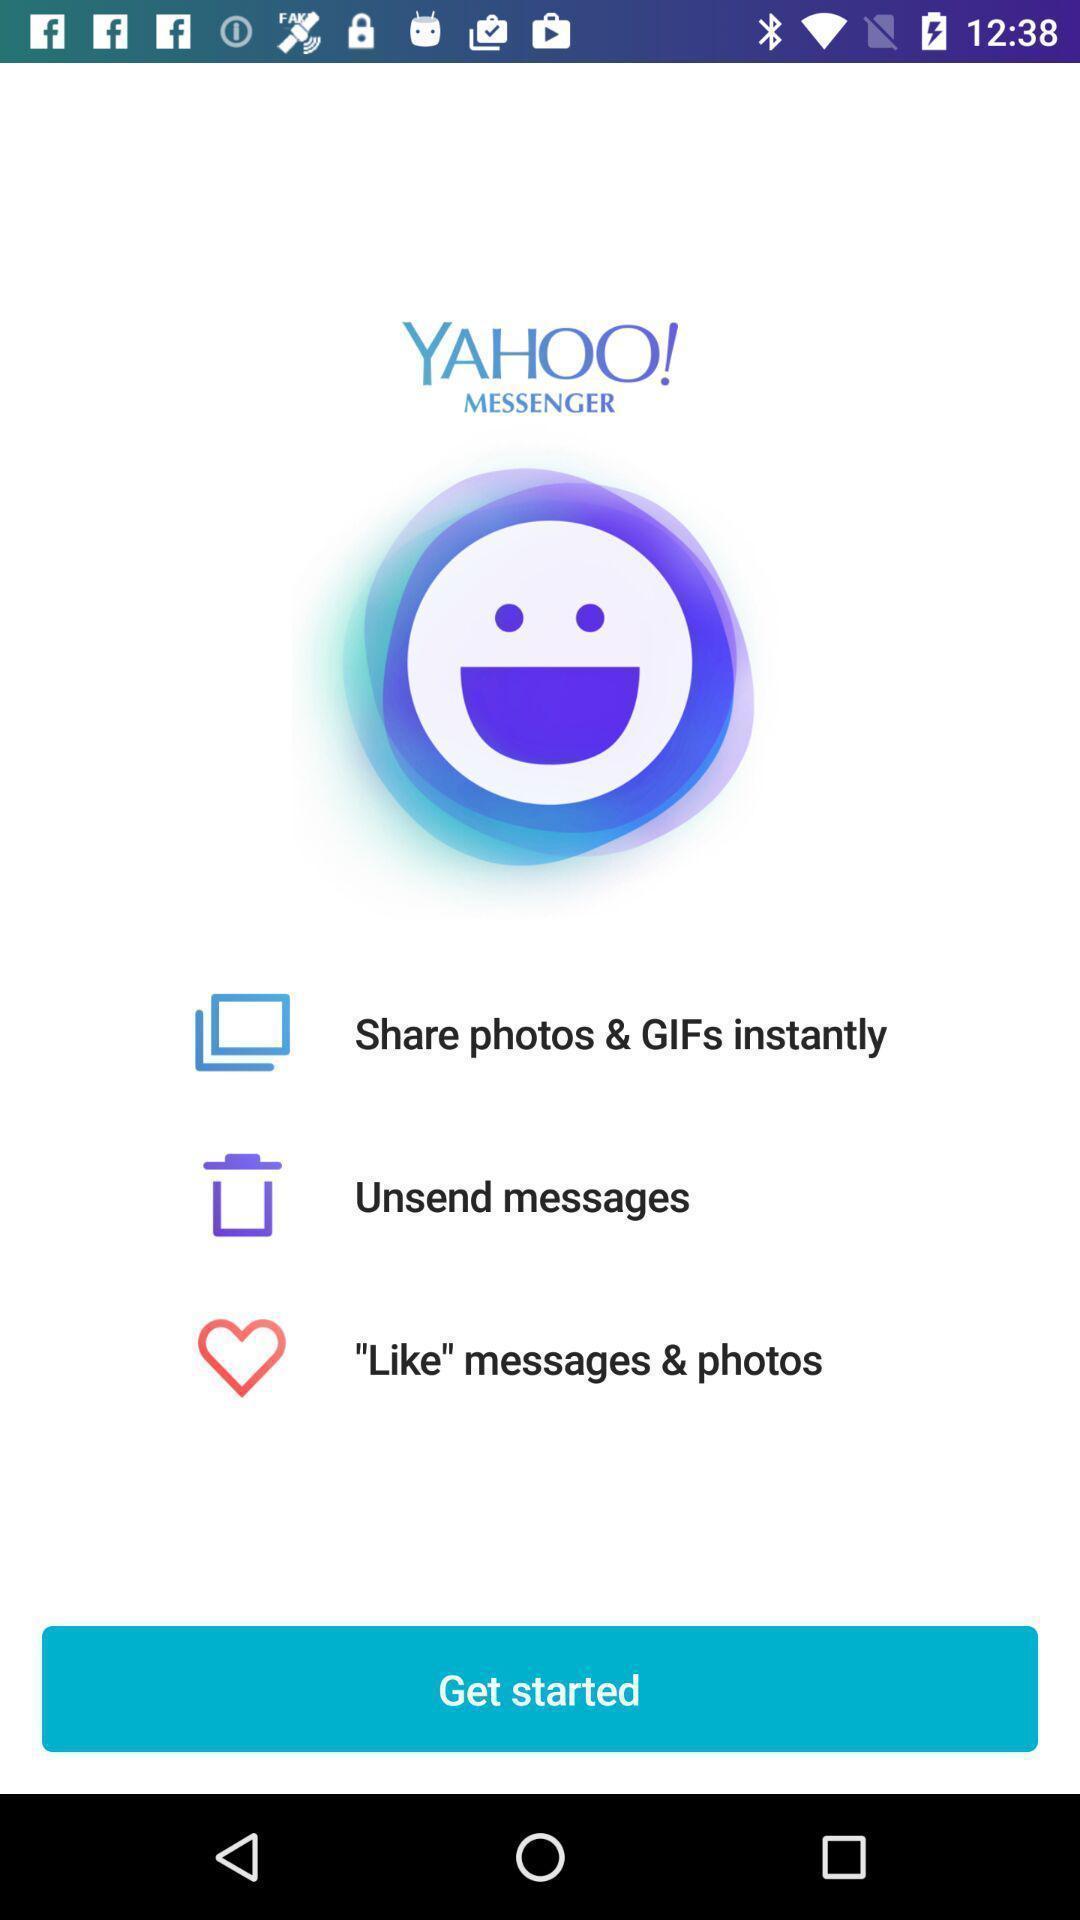Tell me what you see in this picture. Welcome page of a messaging application. 